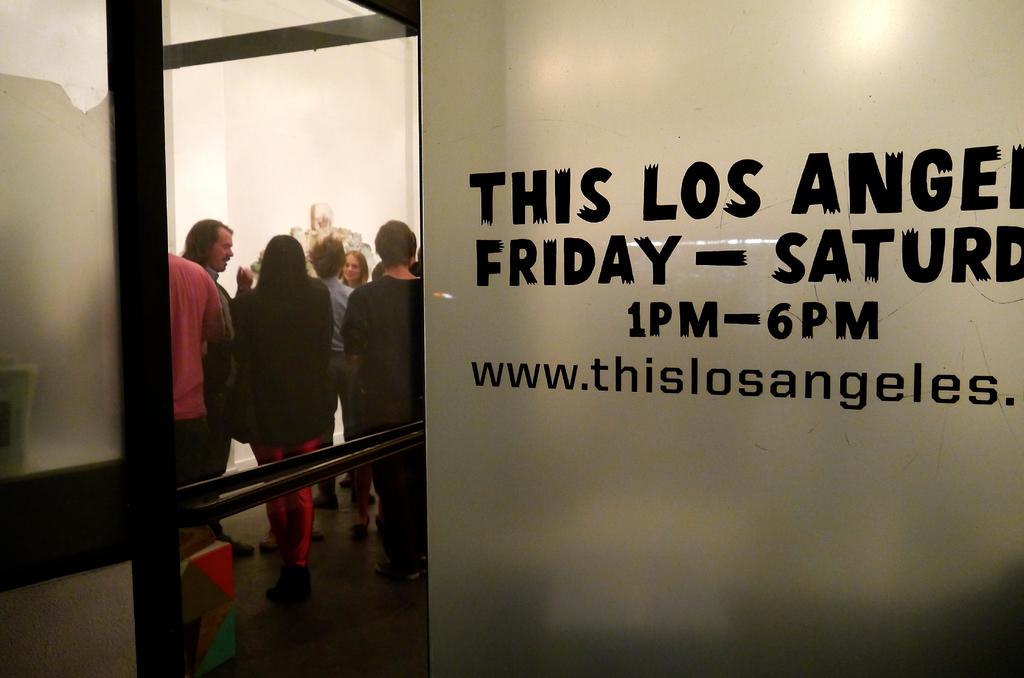Would this event be open on wednesday at 1pm?
Ensure brevity in your answer.  No. 